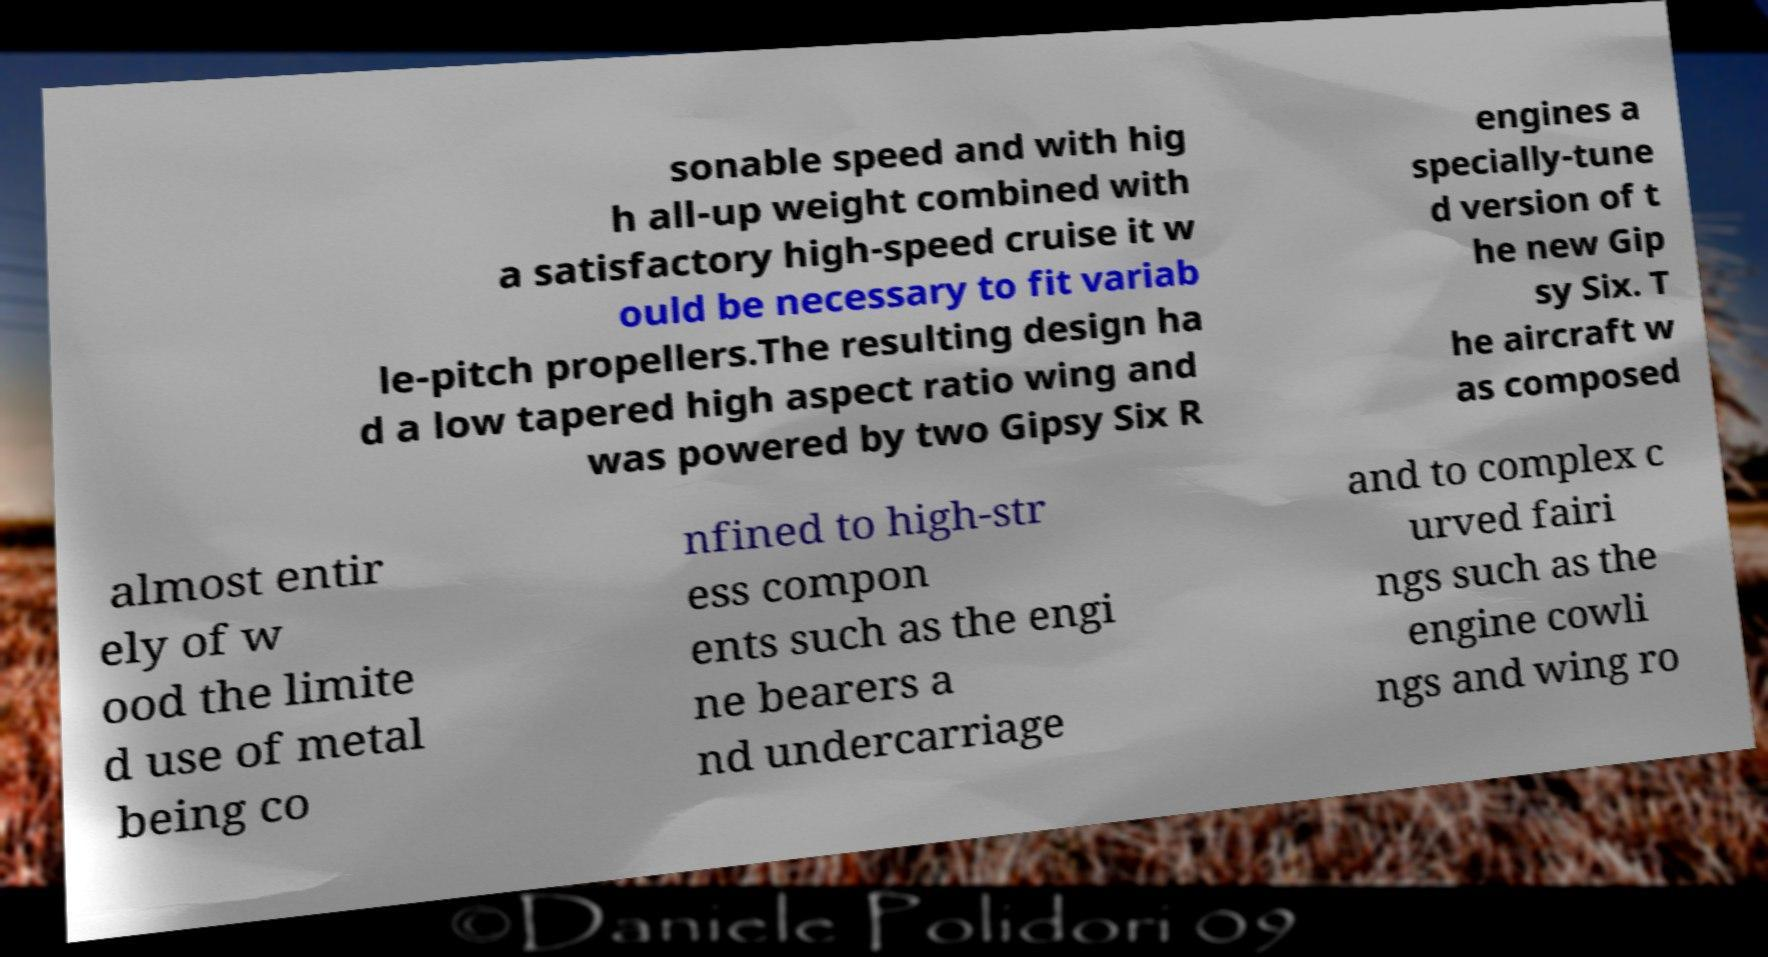Can you read and provide the text displayed in the image?This photo seems to have some interesting text. Can you extract and type it out for me? sonable speed and with hig h all-up weight combined with a satisfactory high-speed cruise it w ould be necessary to fit variab le-pitch propellers.The resulting design ha d a low tapered high aspect ratio wing and was powered by two Gipsy Six R engines a specially-tune d version of t he new Gip sy Six. T he aircraft w as composed almost entir ely of w ood the limite d use of metal being co nfined to high-str ess compon ents such as the engi ne bearers a nd undercarriage and to complex c urved fairi ngs such as the engine cowli ngs and wing ro 